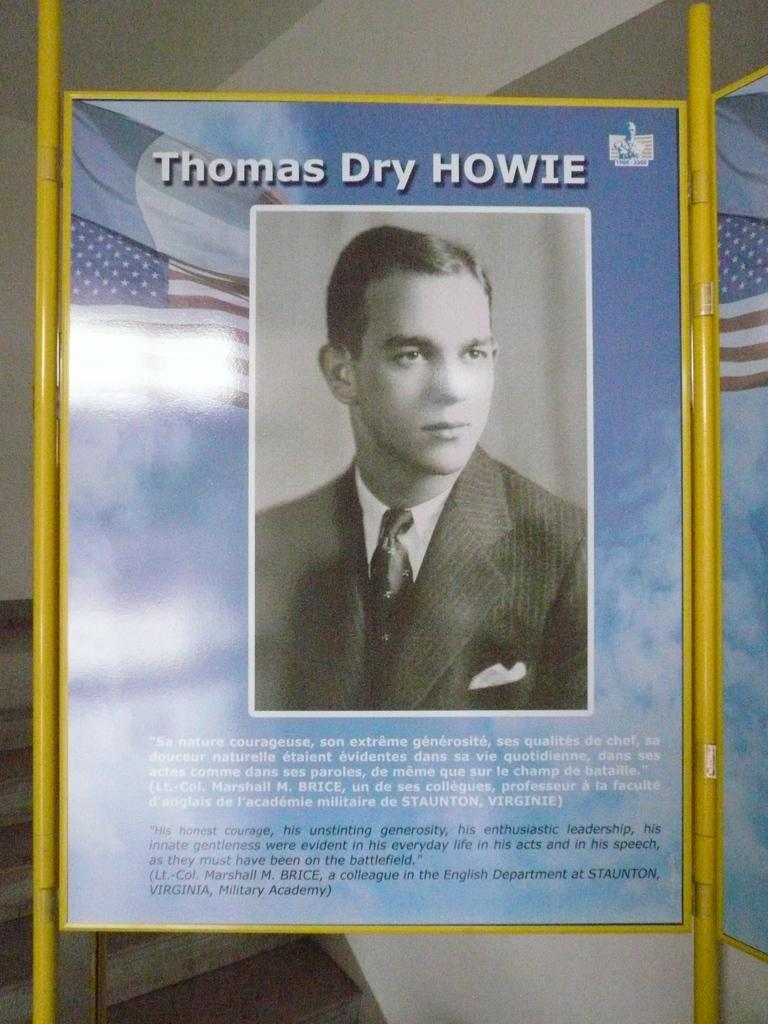<image>
Summarize the visual content of the image. A picture of thomas dry howie and white and black words under his picture 